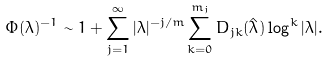<formula> <loc_0><loc_0><loc_500><loc_500>\Phi ( \lambda ) ^ { - 1 } \sim 1 + \sum _ { j = 1 } ^ { \infty } | \lambda | ^ { - j / m } \sum _ { k = 0 } ^ { m _ { j } } D _ { j k } ( \hat { \lambda } ) \log ^ { k } | \lambda | .</formula> 